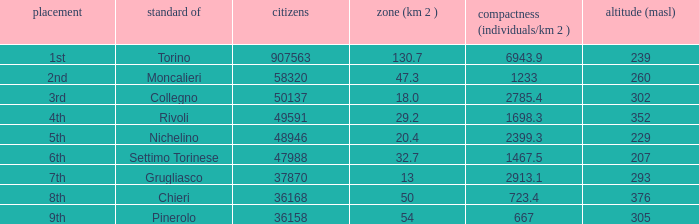How may population figures are given for Settimo Torinese 1.0. 